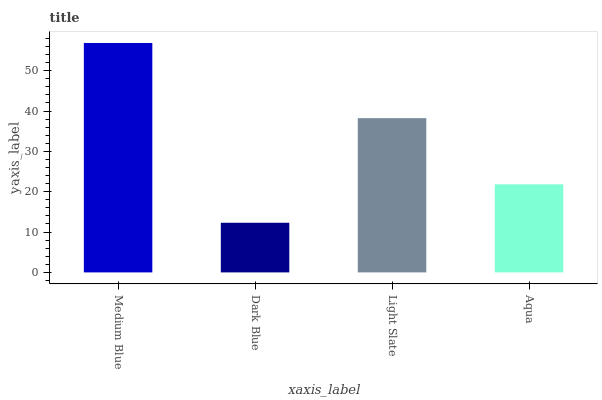Is Light Slate the minimum?
Answer yes or no. No. Is Light Slate the maximum?
Answer yes or no. No. Is Light Slate greater than Dark Blue?
Answer yes or no. Yes. Is Dark Blue less than Light Slate?
Answer yes or no. Yes. Is Dark Blue greater than Light Slate?
Answer yes or no. No. Is Light Slate less than Dark Blue?
Answer yes or no. No. Is Light Slate the high median?
Answer yes or no. Yes. Is Aqua the low median?
Answer yes or no. Yes. Is Dark Blue the high median?
Answer yes or no. No. Is Dark Blue the low median?
Answer yes or no. No. 